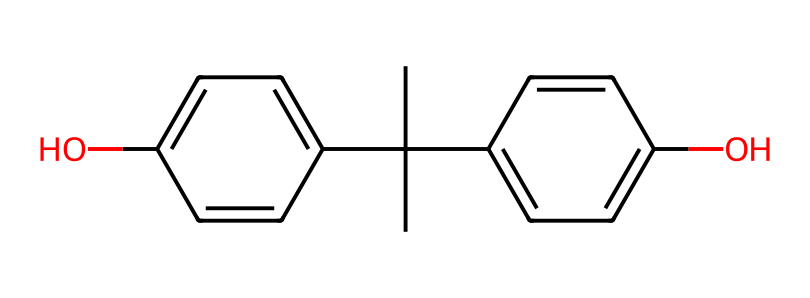What is the basic chemical structure of bisphenol A? The SMILES representation indicates that bisphenol A consists of two phenolic groups (the "C1=CC" and "C2=CC" components) connected by a central carbon atom, highlighting its diphenolic nature.
Answer: diphenolic How many hydroxyl (OH) groups are present in bisphenol A? By examining the structure, there are two -OH groups depicted in the chemical representation, indicating the presence of two hydroxyl groups in bisphenol A.
Answer: two What type of bonding is primarily present in this chemical? The structure reveals several carbon-carbon (C-C) and carbon-oxygen (C-O) bonds, which are characteristic of organic compounds and specific to phenolic structures.
Answer: covalent What functional group is depicted in this chemical? The presence of the -OH groups in the structure confirms that bisphenol A contains phenolic functional groups, classifying it as a phenol.
Answer: phenolic Which part of the structure contributes to its plastic properties? The presence of the central carbon atom connecting the two phenolic groups allows for the formation of polymers, which is crucial for the plastic properties of bisphenol A.
Answer: central carbon 